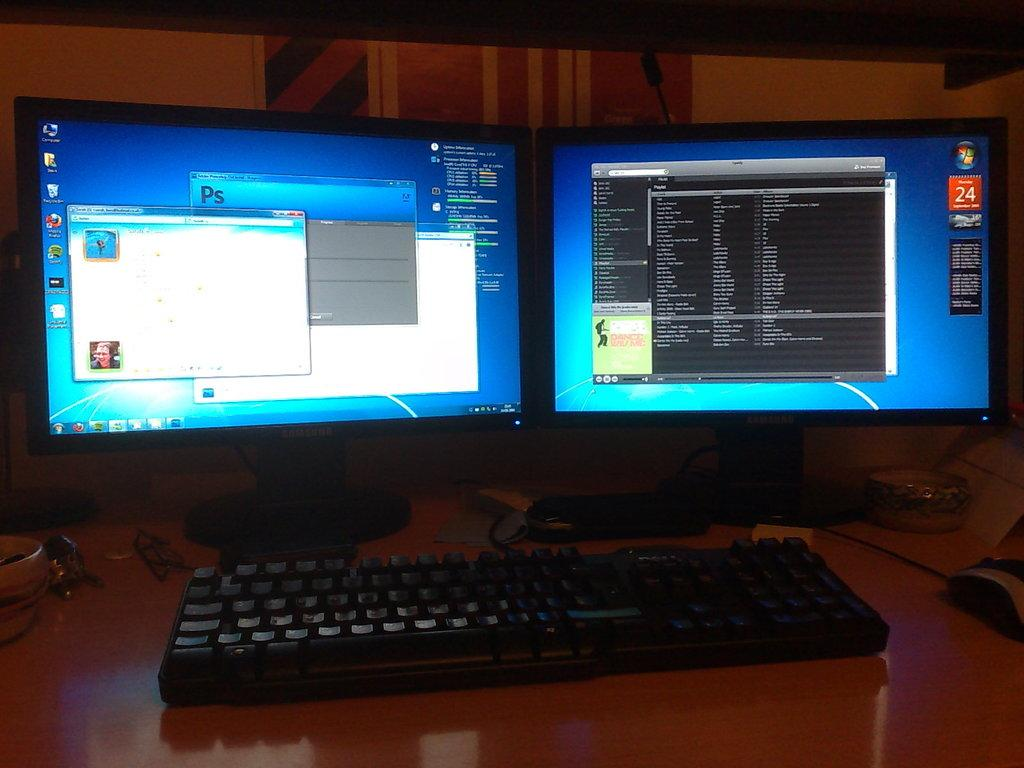<image>
Provide a brief description of the given image. A computer with two monitors that has Adobe Photoshop open. 